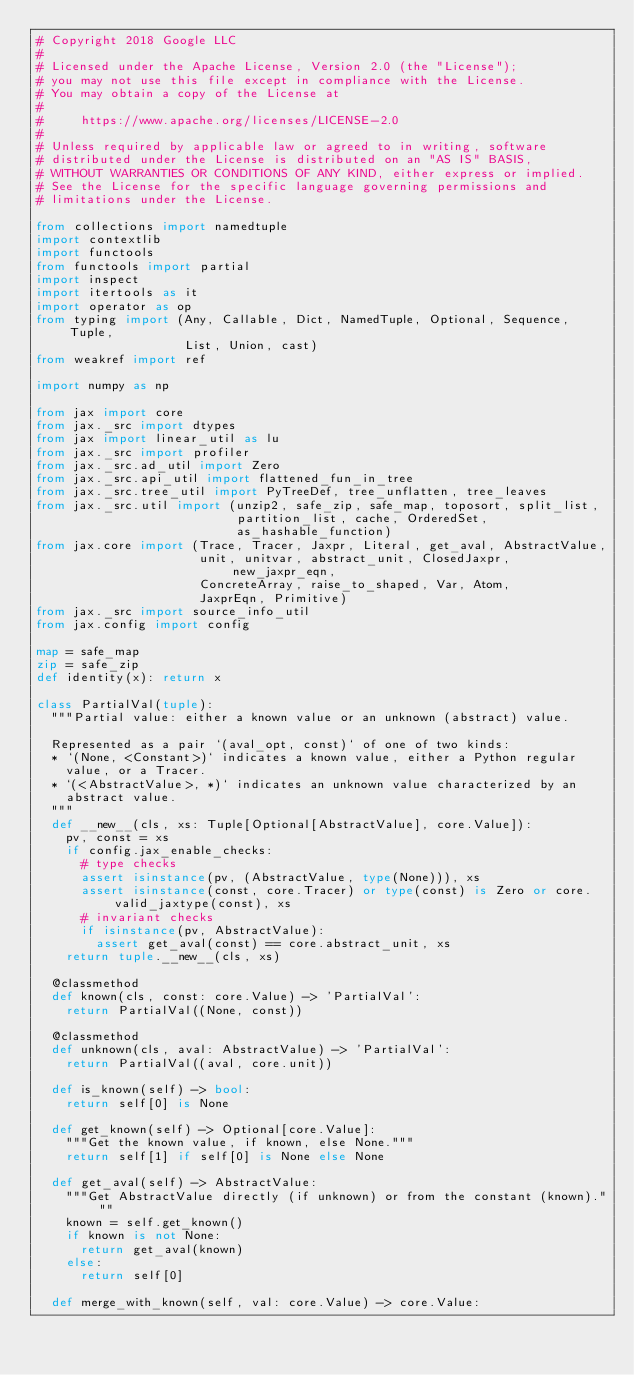<code> <loc_0><loc_0><loc_500><loc_500><_Python_># Copyright 2018 Google LLC
#
# Licensed under the Apache License, Version 2.0 (the "License");
# you may not use this file except in compliance with the License.
# You may obtain a copy of the License at
#
#     https://www.apache.org/licenses/LICENSE-2.0
#
# Unless required by applicable law or agreed to in writing, software
# distributed under the License is distributed on an "AS IS" BASIS,
# WITHOUT WARRANTIES OR CONDITIONS OF ANY KIND, either express or implied.
# See the License for the specific language governing permissions and
# limitations under the License.

from collections import namedtuple
import contextlib
import functools
from functools import partial
import inspect
import itertools as it
import operator as op
from typing import (Any, Callable, Dict, NamedTuple, Optional, Sequence, Tuple,
                    List, Union, cast)
from weakref import ref

import numpy as np

from jax import core
from jax._src import dtypes
from jax import linear_util as lu
from jax._src import profiler
from jax._src.ad_util import Zero
from jax._src.api_util import flattened_fun_in_tree
from jax._src.tree_util import PyTreeDef, tree_unflatten, tree_leaves
from jax._src.util import (unzip2, safe_zip, safe_map, toposort, split_list,
                           partition_list, cache, OrderedSet,
                           as_hashable_function)
from jax.core import (Trace, Tracer, Jaxpr, Literal, get_aval, AbstractValue,
                      unit, unitvar, abstract_unit, ClosedJaxpr, new_jaxpr_eqn,
                      ConcreteArray, raise_to_shaped, Var, Atom,
                      JaxprEqn, Primitive)
from jax._src import source_info_util
from jax.config import config

map = safe_map
zip = safe_zip
def identity(x): return x

class PartialVal(tuple):
  """Partial value: either a known value or an unknown (abstract) value.

  Represented as a pair `(aval_opt, const)` of one of two kinds:
  * `(None, <Constant>)` indicates a known value, either a Python regular
    value, or a Tracer.
  * `(<AbstractValue>, *)` indicates an unknown value characterized by an
    abstract value.
  """
  def __new__(cls, xs: Tuple[Optional[AbstractValue], core.Value]):
    pv, const = xs
    if config.jax_enable_checks:
      # type checks
      assert isinstance(pv, (AbstractValue, type(None))), xs
      assert isinstance(const, core.Tracer) or type(const) is Zero or core.valid_jaxtype(const), xs
      # invariant checks
      if isinstance(pv, AbstractValue):
        assert get_aval(const) == core.abstract_unit, xs
    return tuple.__new__(cls, xs)

  @classmethod
  def known(cls, const: core.Value) -> 'PartialVal':
    return PartialVal((None, const))

  @classmethod
  def unknown(cls, aval: AbstractValue) -> 'PartialVal':
    return PartialVal((aval, core.unit))

  def is_known(self) -> bool:
    return self[0] is None

  def get_known(self) -> Optional[core.Value]:
    """Get the known value, if known, else None."""
    return self[1] if self[0] is None else None

  def get_aval(self) -> AbstractValue:
    """Get AbstractValue directly (if unknown) or from the constant (known)."""
    known = self.get_known()
    if known is not None:
      return get_aval(known)
    else:
      return self[0]

  def merge_with_known(self, val: core.Value) -> core.Value:</code> 